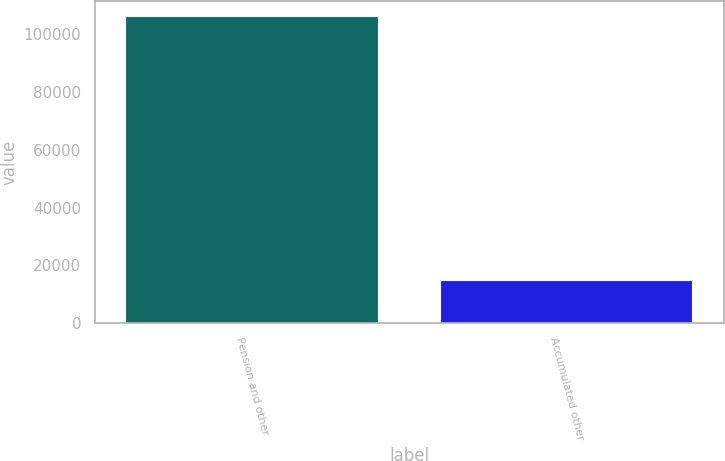<chart> <loc_0><loc_0><loc_500><loc_500><bar_chart><fcel>Pension and other<fcel>Accumulated other<nl><fcel>106155<fcel>14638<nl></chart> 